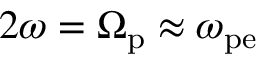Convert formula to latex. <formula><loc_0><loc_0><loc_500><loc_500>2 \omega = \Omega _ { p } \approx \omega _ { p e }</formula> 